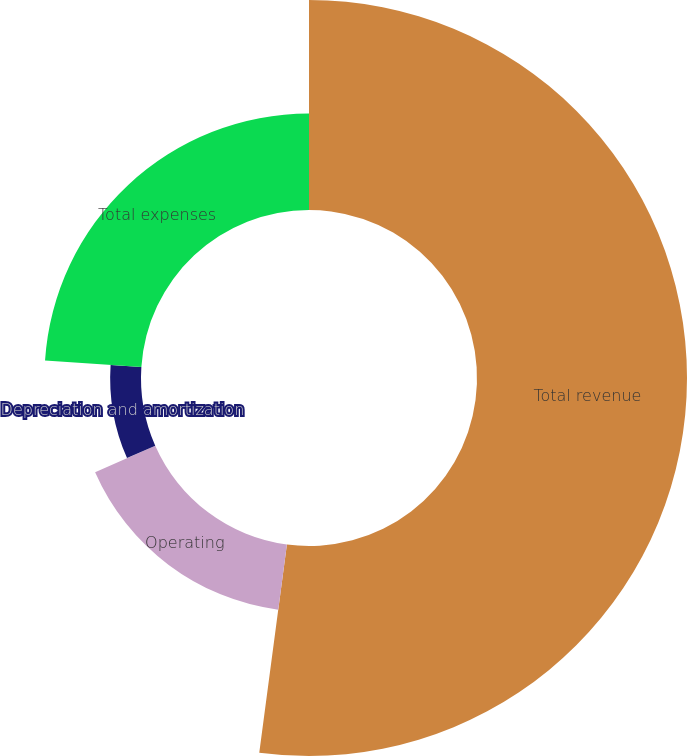Convert chart to OTSL. <chart><loc_0><loc_0><loc_500><loc_500><pie_chart><fcel>Total revenue<fcel>Operating<fcel>Depreciation and amortization<fcel>Total expenses<nl><fcel>52.1%<fcel>16.3%<fcel>7.65%<fcel>23.95%<nl></chart> 